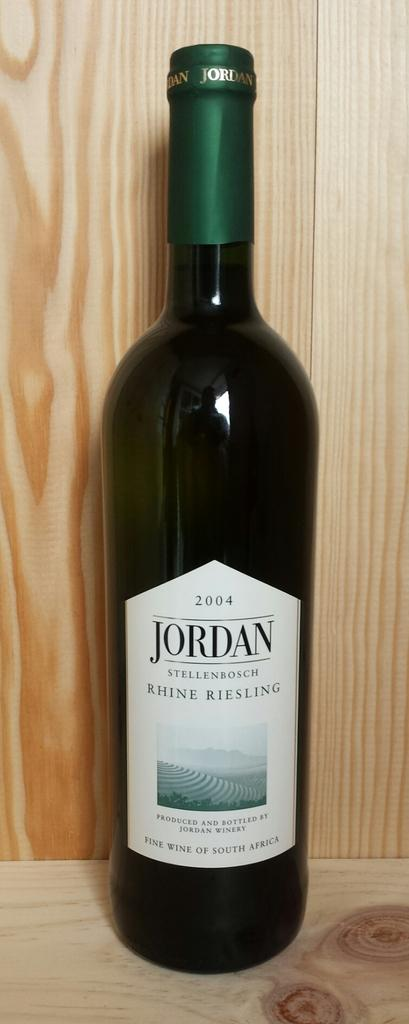Provide a one-sentence caption for the provided image. A 2004 bottle of wine has a label that says Jordan. 